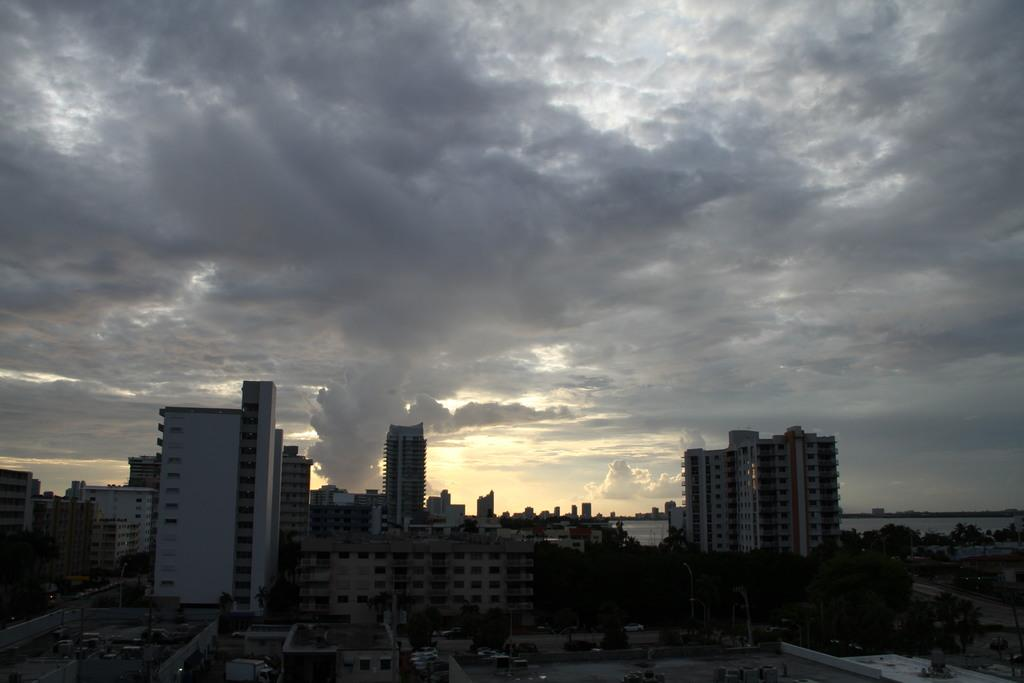What type of structures can be seen in the image? There are buildings and towers in the image. What type of vegetation is present in the image? There are trees in the image. What is visible at the top of the image? There are clouds visible at the top of the image. What type of cream is being used to paint the buildings in the image? There is no cream or painting activity present in the image; the buildings are simply standing structures. 